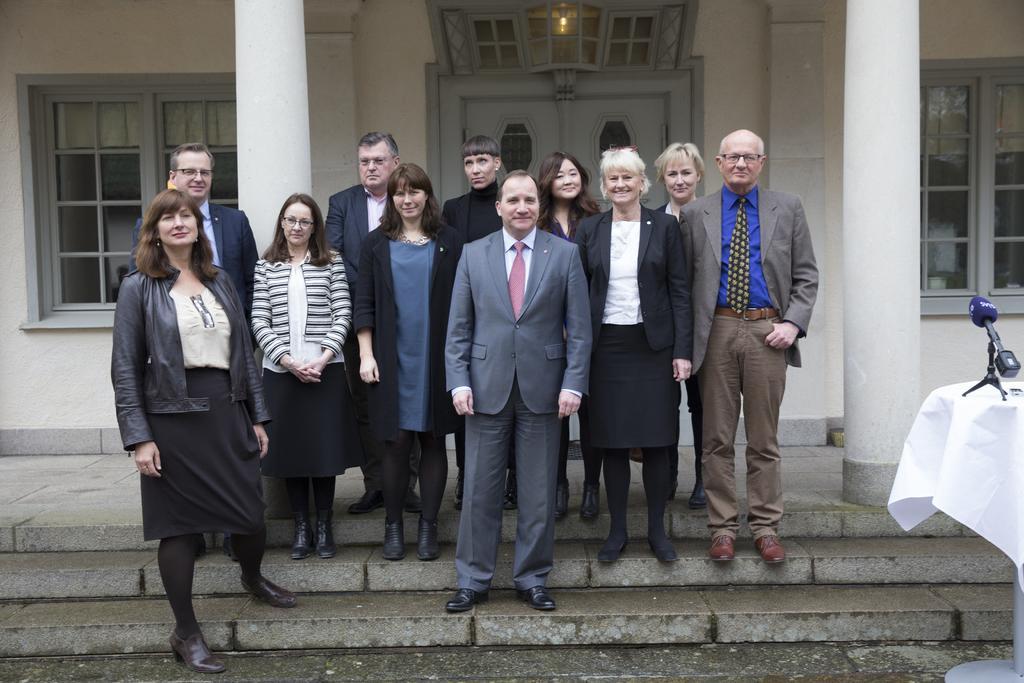In one or two sentences, can you explain what this image depicts? In this picture I can see there are a group of people standing here and there are few men and women standing. The woman on to left is wearing a skirt and a coat and the men are wearing blazers and shirts and in the backdrop I can see there is a building and it has a door, windows and there are two pillars. 